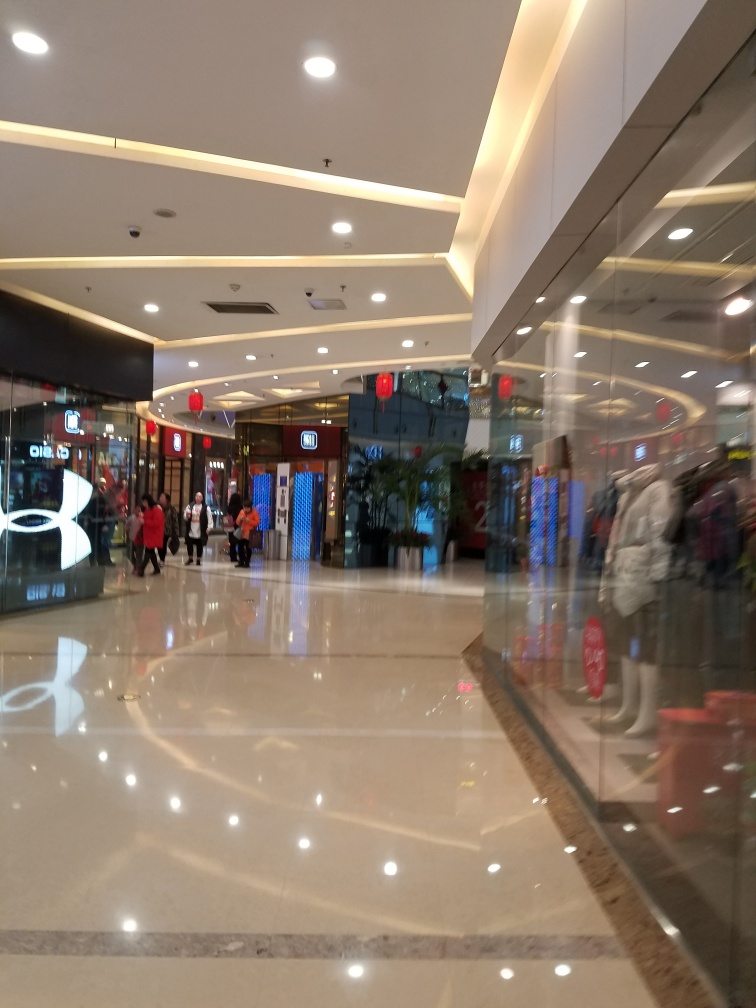Are there any quality issues with this image? Yes, there are several quality issues with the image at hand. It appears to be slightly blurry, mainly due to motion or camera shake, which impacts the sharpness of details. There's noticeable glare reflected on the shiny floor and some areas are overexposed due to the lighting conditions. Moreover, the composition could be better framed to enhance visual alignment and balance. 